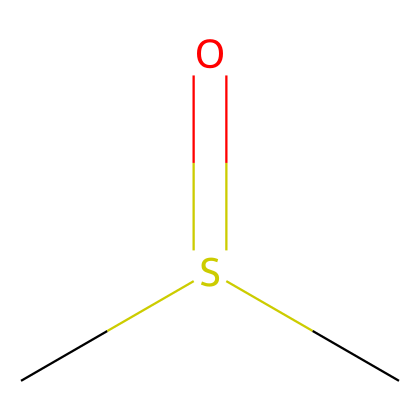How many carbon atoms are in dimethyl sulfoxide? The SMILES representation "CS(=O)C" indicates there are two "C" letters present, which correspond to two carbon atoms.
Answer: two What is the functional group present in this compound? The presence of the "S(=O)" part in the SMILES suggests a sulfoxide functional group, which is characterized by a sulfur atom bonded to an oxygen atom via a double bond and to a carbon atom.
Answer: sulfoxide How many hydrogen atoms are in dimethyl sulfoxide? From the SMILES "CS(=O)C", each carbon (C) is typically bonded to three hydrogens, but since one of the carbons is bonded to the sulfur, it can instead bond to only two hydrogens. Thus, we have (2 carbons x 3 hydrogen) - 1 (for the carbon bonded to sulfur) = 5 hydrogen atoms.
Answer: six What is the oxidation state of sulfur in this compound? The sulfur atom in dimethyl sulfoxide is in the +2 oxidation state as it is bonded to a double-bonded oxygen (oxidation state of +2 for oxygen) and two carbon atoms (each carbon contributes no change to the oxidation state).
Answer: two What type of bonding exists between the sulfur and oxygen atoms in DMSO? The SMILES notation "S(=O)" indicates that sulfur is bonded to oxygen with a double bond, which represents a strong covalent bond typical in sulfoxides.
Answer: double bond What specific type of organosulfur compound is dimethyl sulfoxide classified as? DMSO is classified as a sulfoxide, which is a type of organosulfur compound characterized by a sulfur atom bonded to two carbon atoms and to one oxygen through a double bond.
Answer: sulfoxide 